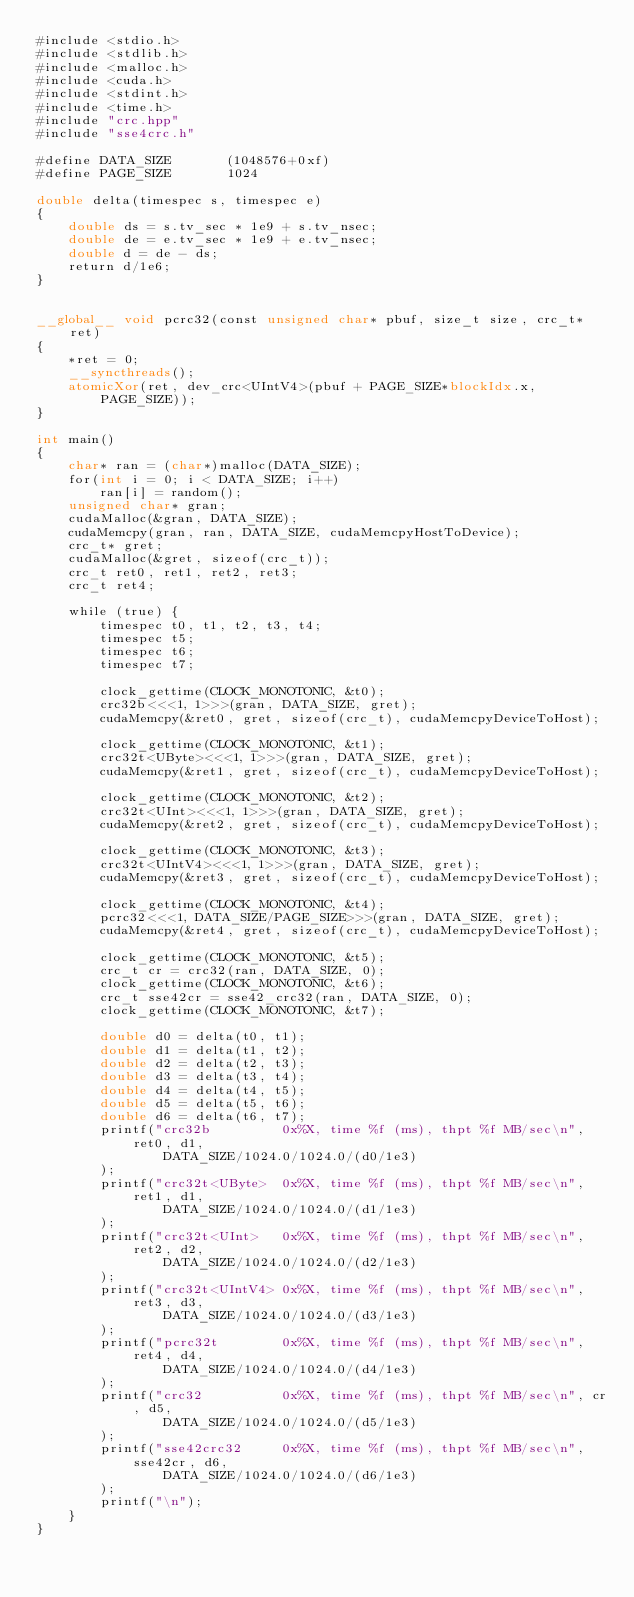Convert code to text. <code><loc_0><loc_0><loc_500><loc_500><_Cuda_>#include <stdio.h>
#include <stdlib.h>
#include <malloc.h>
#include <cuda.h>
#include <stdint.h>
#include <time.h>
#include "crc.hpp"
#include "sse4crc.h"

#define DATA_SIZE		(1048576+0xf)
#define PAGE_SIZE		1024

double delta(timespec s, timespec e)
{
	double ds = s.tv_sec * 1e9 + s.tv_nsec;
	double de = e.tv_sec * 1e9 + e.tv_nsec;
	double d = de - ds;
	return d/1e6;
}


__global__ void pcrc32(const unsigned char* pbuf, size_t size, crc_t* ret)
{
	*ret = 0;
	__syncthreads();
	atomicXor(ret, dev_crc<UIntV4>(pbuf + PAGE_SIZE*blockIdx.x, PAGE_SIZE));
}

int main()
{
	char* ran = (char*)malloc(DATA_SIZE);
	for(int i = 0; i < DATA_SIZE; i++)
		ran[i] = random();
	unsigned char* gran;
	cudaMalloc(&gran, DATA_SIZE);
	cudaMemcpy(gran, ran, DATA_SIZE, cudaMemcpyHostToDevice);
	crc_t* gret;
	cudaMalloc(&gret, sizeof(crc_t));
	crc_t ret0, ret1, ret2, ret3;
	crc_t ret4;

	while (true) {
		timespec t0, t1, t2, t3, t4;
		timespec t5;
		timespec t6;
		timespec t7;

		clock_gettime(CLOCK_MONOTONIC, &t0);
		crc32b<<<1, 1>>>(gran, DATA_SIZE, gret);
		cudaMemcpy(&ret0, gret, sizeof(crc_t), cudaMemcpyDeviceToHost);

		clock_gettime(CLOCK_MONOTONIC, &t1);
		crc32t<UByte><<<1, 1>>>(gran, DATA_SIZE, gret);
		cudaMemcpy(&ret1, gret, sizeof(crc_t), cudaMemcpyDeviceToHost);

		clock_gettime(CLOCK_MONOTONIC, &t2);
		crc32t<UInt><<<1, 1>>>(gran, DATA_SIZE, gret);
		cudaMemcpy(&ret2, gret, sizeof(crc_t), cudaMemcpyDeviceToHost);

		clock_gettime(CLOCK_MONOTONIC, &t3);
		crc32t<UIntV4><<<1, 1>>>(gran, DATA_SIZE, gret);
		cudaMemcpy(&ret3, gret, sizeof(crc_t), cudaMemcpyDeviceToHost);

		clock_gettime(CLOCK_MONOTONIC, &t4);
		pcrc32<<<1, DATA_SIZE/PAGE_SIZE>>>(gran, DATA_SIZE, gret);
		cudaMemcpy(&ret4, gret, sizeof(crc_t), cudaMemcpyDeviceToHost);

		clock_gettime(CLOCK_MONOTONIC, &t5);
		crc_t cr = crc32(ran, DATA_SIZE, 0);
		clock_gettime(CLOCK_MONOTONIC, &t6);
		crc_t sse42cr = sse42_crc32(ran, DATA_SIZE, 0);
		clock_gettime(CLOCK_MONOTONIC, &t7);

		double d0 = delta(t0, t1);
		double d1 = delta(t1, t2);
		double d2 = delta(t2, t3);
		double d3 = delta(t3, t4);
		double d4 = delta(t4, t5);
		double d5 = delta(t5, t6);
		double d6 = delta(t6, t7);
		printf("crc32b         0x%X, time %f (ms), thpt %f MB/sec\n", ret0, d1,
				DATA_SIZE/1024.0/1024.0/(d0/1e3)
		);
		printf("crc32t<UByte>  0x%X, time %f (ms), thpt %f MB/sec\n", ret1, d1,
				DATA_SIZE/1024.0/1024.0/(d1/1e3)
		);
		printf("crc32t<UInt>   0x%X, time %f (ms), thpt %f MB/sec\n", ret2, d2,
				DATA_SIZE/1024.0/1024.0/(d2/1e3)
		);
		printf("crc32t<UIntV4> 0x%X, time %f (ms), thpt %f MB/sec\n", ret3, d3,
				DATA_SIZE/1024.0/1024.0/(d3/1e3)
		);
		printf("pcrc32t        0x%X, time %f (ms), thpt %f MB/sec\n", ret4, d4,
				DATA_SIZE/1024.0/1024.0/(d4/1e3)
		);
		printf("crc32          0x%X, time %f (ms), thpt %f MB/sec\n", cr, d5,
				DATA_SIZE/1024.0/1024.0/(d5/1e3)
		);
		printf("sse42crc32     0x%X, time %f (ms), thpt %f MB/sec\n", sse42cr, d6,
				DATA_SIZE/1024.0/1024.0/(d6/1e3)
		);
		printf("\n");
	}
}
</code> 